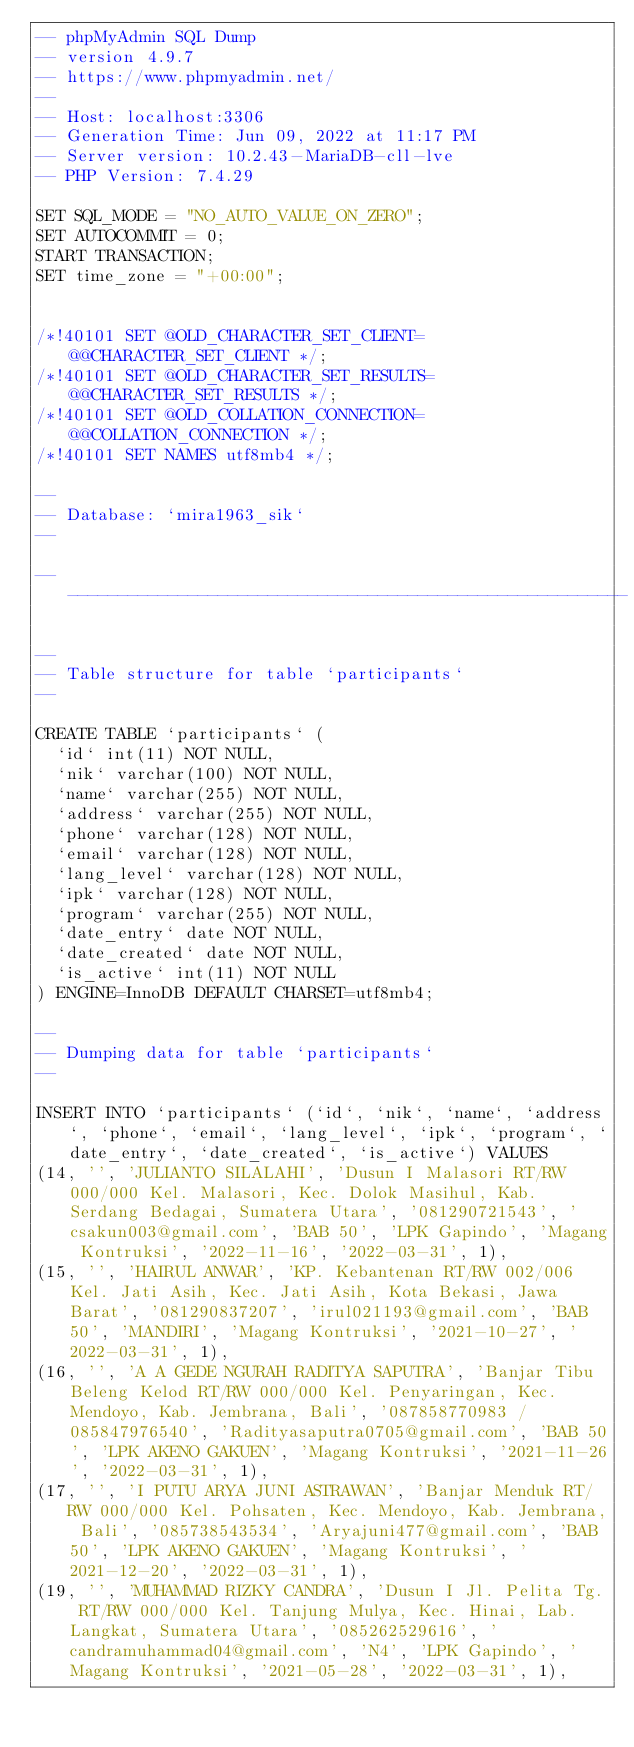<code> <loc_0><loc_0><loc_500><loc_500><_SQL_>-- phpMyAdmin SQL Dump
-- version 4.9.7
-- https://www.phpmyadmin.net/
--
-- Host: localhost:3306
-- Generation Time: Jun 09, 2022 at 11:17 PM
-- Server version: 10.2.43-MariaDB-cll-lve
-- PHP Version: 7.4.29

SET SQL_MODE = "NO_AUTO_VALUE_ON_ZERO";
SET AUTOCOMMIT = 0;
START TRANSACTION;
SET time_zone = "+00:00";


/*!40101 SET @OLD_CHARACTER_SET_CLIENT=@@CHARACTER_SET_CLIENT */;
/*!40101 SET @OLD_CHARACTER_SET_RESULTS=@@CHARACTER_SET_RESULTS */;
/*!40101 SET @OLD_COLLATION_CONNECTION=@@COLLATION_CONNECTION */;
/*!40101 SET NAMES utf8mb4 */;

--
-- Database: `mira1963_sik`
--

-- --------------------------------------------------------

--
-- Table structure for table `participants`
--

CREATE TABLE `participants` (
  `id` int(11) NOT NULL,
  `nik` varchar(100) NOT NULL,
  `name` varchar(255) NOT NULL,
  `address` varchar(255) NOT NULL,
  `phone` varchar(128) NOT NULL,
  `email` varchar(128) NOT NULL,
  `lang_level` varchar(128) NOT NULL,
  `ipk` varchar(128) NOT NULL,
  `program` varchar(255) NOT NULL,
  `date_entry` date NOT NULL,
  `date_created` date NOT NULL,
  `is_active` int(11) NOT NULL
) ENGINE=InnoDB DEFAULT CHARSET=utf8mb4;

--
-- Dumping data for table `participants`
--

INSERT INTO `participants` (`id`, `nik`, `name`, `address`, `phone`, `email`, `lang_level`, `ipk`, `program`, `date_entry`, `date_created`, `is_active`) VALUES
(14, '', 'JULIANTO SILALAHI', 'Dusun I Malasori RT/RW 000/000 Kel. Malasori, Kec. Dolok Masihul, Kab. Serdang Bedagai, Sumatera Utara', '081290721543', 'csakun003@gmail.com', 'BAB 50', 'LPK Gapindo', 'Magang Kontruksi', '2022-11-16', '2022-03-31', 1),
(15, '', 'HAIRUL ANWAR', 'KP. Kebantenan RT/RW 002/006 Kel. Jati Asih, Kec. Jati Asih, Kota Bekasi, Jawa Barat', '081290837207', 'irul021193@gmail.com', 'BAB 50', 'MANDIRI', 'Magang Kontruksi', '2021-10-27', '2022-03-31', 1),
(16, '', 'A A GEDE NGURAH RADITYA SAPUTRA', 'Banjar Tibu Beleng Kelod RT/RW 000/000 Kel. Penyaringan, Kec. Mendoyo, Kab. Jembrana, Bali', '087858770983 / 085847976540', 'Radityasaputra0705@gmail.com', 'BAB 50', 'LPK AKENO GAKUEN', 'Magang Kontruksi', '2021-11-26', '2022-03-31', 1),
(17, '', 'I PUTU ARYA JUNI ASTRAWAN', 'Banjar Menduk RT/RW 000/000 Kel. Pohsaten, Kec. Mendoyo, Kab. Jembrana, Bali', '085738543534', 'Aryajuni477@gmail.com', 'BAB 50', 'LPK AKENO GAKUEN', 'Magang Kontruksi', '2021-12-20', '2022-03-31', 1),
(19, '', 'MUHAMMAD RIZKY CANDRA', 'Dusun I Jl. Pelita Tg. RT/RW 000/000 Kel. Tanjung Mulya, Kec. Hinai, Lab. Langkat, Sumatera Utara', '085262529616', 'candramuhammad04@gmail.com', 'N4', 'LPK Gapindo', 'Magang Kontruksi', '2021-05-28', '2022-03-31', 1),</code> 